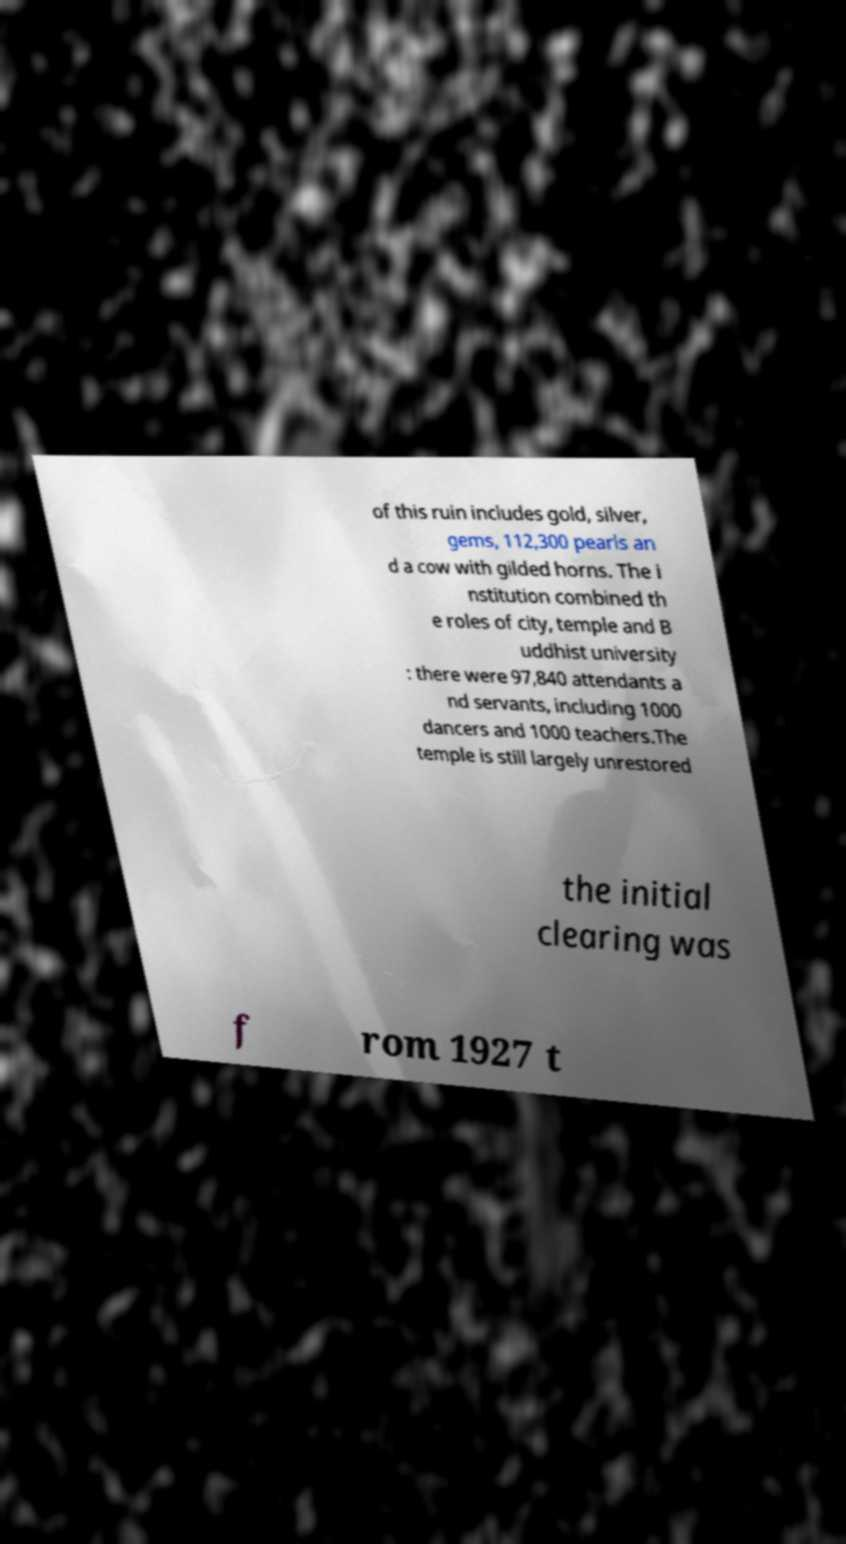What messages or text are displayed in this image? I need them in a readable, typed format. of this ruin includes gold, silver, gems, 112,300 pearls an d a cow with gilded horns. The i nstitution combined th e roles of city, temple and B uddhist university : there were 97,840 attendants a nd servants, including 1000 dancers and 1000 teachers.The temple is still largely unrestored the initial clearing was f rom 1927 t 